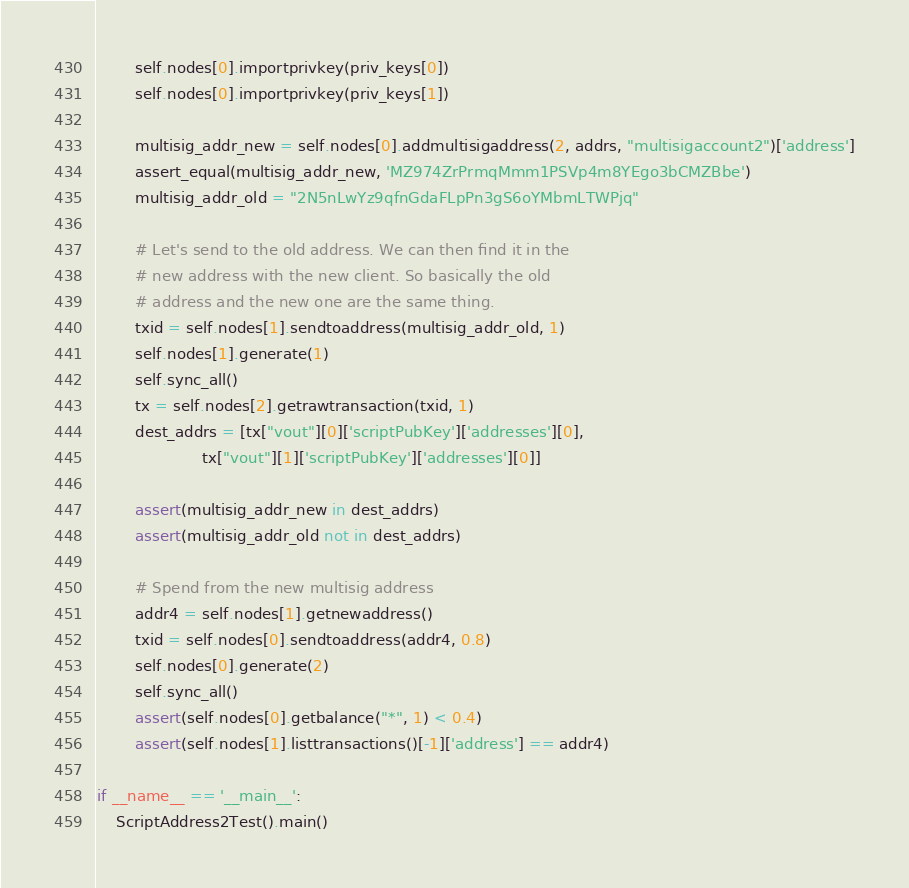Convert code to text. <code><loc_0><loc_0><loc_500><loc_500><_Python_>        self.nodes[0].importprivkey(priv_keys[0])
        self.nodes[0].importprivkey(priv_keys[1])

        multisig_addr_new = self.nodes[0].addmultisigaddress(2, addrs, "multisigaccount2")['address']
        assert_equal(multisig_addr_new, 'MZ974ZrPrmqMmm1PSVp4m8YEgo3bCMZBbe')
        multisig_addr_old = "2N5nLwYz9qfnGdaFLpPn3gS6oYMbmLTWPjq"

        # Let's send to the old address. We can then find it in the
        # new address with the new client. So basically the old
        # address and the new one are the same thing.
        txid = self.nodes[1].sendtoaddress(multisig_addr_old, 1)
        self.nodes[1].generate(1)
        self.sync_all()
        tx = self.nodes[2].getrawtransaction(txid, 1)
        dest_addrs = [tx["vout"][0]['scriptPubKey']['addresses'][0],
                      tx["vout"][1]['scriptPubKey']['addresses'][0]]

        assert(multisig_addr_new in dest_addrs)
        assert(multisig_addr_old not in dest_addrs)

        # Spend from the new multisig address
        addr4 = self.nodes[1].getnewaddress()
        txid = self.nodes[0].sendtoaddress(addr4, 0.8)
        self.nodes[0].generate(2)
        self.sync_all()
        assert(self.nodes[0].getbalance("*", 1) < 0.4)
        assert(self.nodes[1].listtransactions()[-1]['address'] == addr4)

if __name__ == '__main__':
    ScriptAddress2Test().main()
</code> 